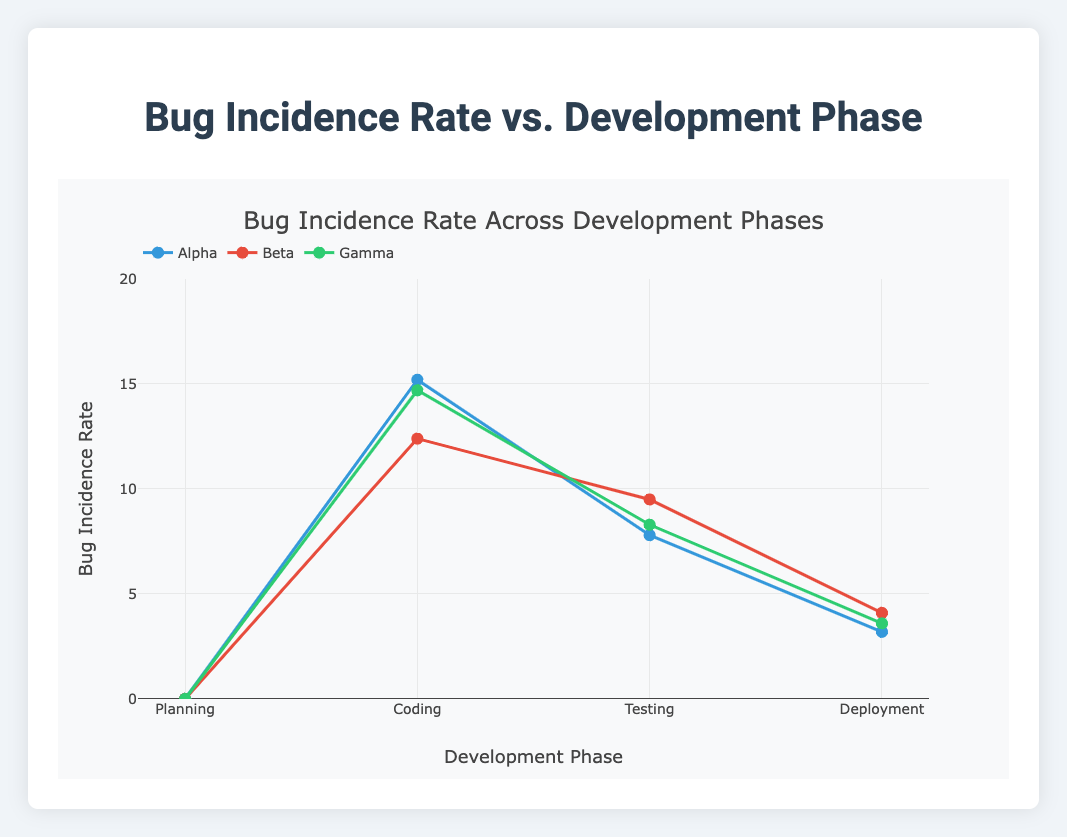What is the title of the figure? The title is displayed at the top of the plot.
Answer: Bug Incidence Rate Across Development Phases How many projects are shown in the scatter plot? Each trace represents a project, identifiable by unique colors and names in the legend.
Answer: 3 During which development phase does the project 'Beta' have the highest bug incidence rate? By observing the 'Beta' trace in the scatter plot, we can see that its highest bug incidence rate occurs during the Coding phase.
Answer: Coding What is the bug incidence rate for the project 'Gamma' during the Testing phase? Locate the point corresponding to 'Gamma' in the Testing phase to read the y-value.
Answer: 8.3 Which project has the lowest bug incidence rate during the Deployment phase? Compare the y-values of all projects during the Deployment phase and identify the lowest.
Answer: Alpha How does the bug incidence rate trend change from Coding to Testing for all projects? Observe the changes in bug incidence from Coding to Testing for each project: for Alpha, it decreases from 15.2 to 7.8; for Beta, it decreases from 12.4 to 9.5; and for Gamma, it decreases from 14.7 to 8.3.
Answer: Decreases What is the bug incidence rate difference between the Coding and Deployment phases for the project 'Alpha'? Find 'Alpha's values for Coding and Deployment phases, and subtract the Deployment rate from the Coding rate (15.2 - 3.2).
Answer: 12 Which development phase has zero bug incidence rates for all projects? Check each phase for any zero values and confirm that the Planning phase is the only one with a zero bug incidence rate for all projects.
Answer: Planning Compare the bug incidence rates for the project 'Beta' in the Testing and Deployment phases. Which phase has the higher rate and by how much? Identify the rates of Beta in Testing (9.5) and Deployment (4.1), and calculate the difference between them (9.5 - 4.1).
Answer: Testing, by 5.4 What is the average bug incidence rate during the Testing phase for all projects? Sum the bug rates for all projects during Testing (7.8 for Alpha, 9.5 for Beta, 8.3 for Gamma) and divide by the number of projects (3).
Answer: 8.53 